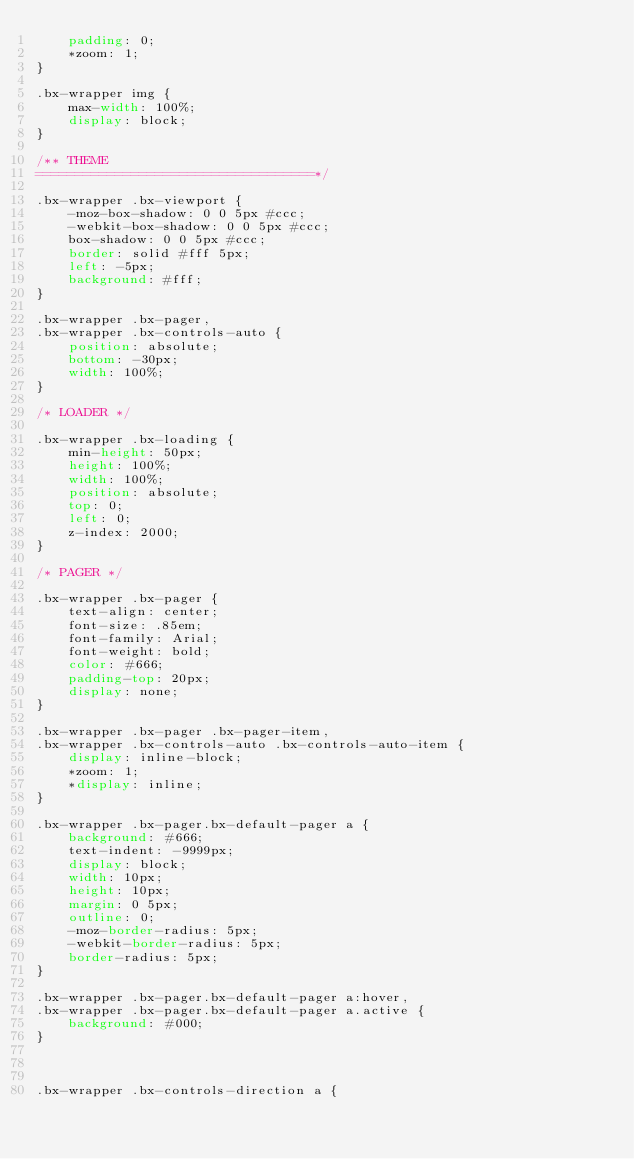Convert code to text. <code><loc_0><loc_0><loc_500><loc_500><_CSS_>	padding: 0;
	*zoom: 1;
}

.bx-wrapper img {
	max-width: 100%;
	display: block;
}

/** THEME
===================================*/

.bx-wrapper .bx-viewport {
	-moz-box-shadow: 0 0 5px #ccc;
	-webkit-box-shadow: 0 0 5px #ccc;
	box-shadow: 0 0 5px #ccc;
	border: solid #fff 5px;
	left: -5px;
	background: #fff;
}

.bx-wrapper .bx-pager,
.bx-wrapper .bx-controls-auto {
	position: absolute;
	bottom: -30px;
	width: 100%;
}

/* LOADER */

.bx-wrapper .bx-loading {
	min-height: 50px;
	height: 100%;
	width: 100%;
	position: absolute;
	top: 0;
	left: 0;
	z-index: 2000;
}

/* PAGER */

.bx-wrapper .bx-pager {
	text-align: center;
	font-size: .85em;
	font-family: Arial;
	font-weight: bold;
	color: #666;
	padding-top: 20px;
	display: none;
}

.bx-wrapper .bx-pager .bx-pager-item,
.bx-wrapper .bx-controls-auto .bx-controls-auto-item {
	display: inline-block;
	*zoom: 1;
	*display: inline;
}

.bx-wrapper .bx-pager.bx-default-pager a {
	background: #666;
	text-indent: -9999px;
	display: block;
	width: 10px;
	height: 10px;
	margin: 0 5px;
	outline: 0;
	-moz-border-radius: 5px;
	-webkit-border-radius: 5px;
	border-radius: 5px;
}

.bx-wrapper .bx-pager.bx-default-pager a:hover,
.bx-wrapper .bx-pager.bx-default-pager a.active {
	background: #000;
}



.bx-wrapper .bx-controls-direction a {</code> 